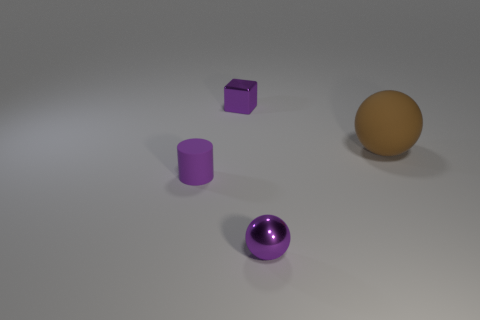Add 2 matte cylinders. How many objects exist? 6 Subtract all blocks. How many objects are left? 3 Add 3 big objects. How many big objects exist? 4 Subtract 1 brown balls. How many objects are left? 3 Subtract all cyan cylinders. Subtract all blue blocks. How many cylinders are left? 1 Subtract all brown objects. Subtract all brown rubber objects. How many objects are left? 2 Add 4 purple metallic balls. How many purple metallic balls are left? 5 